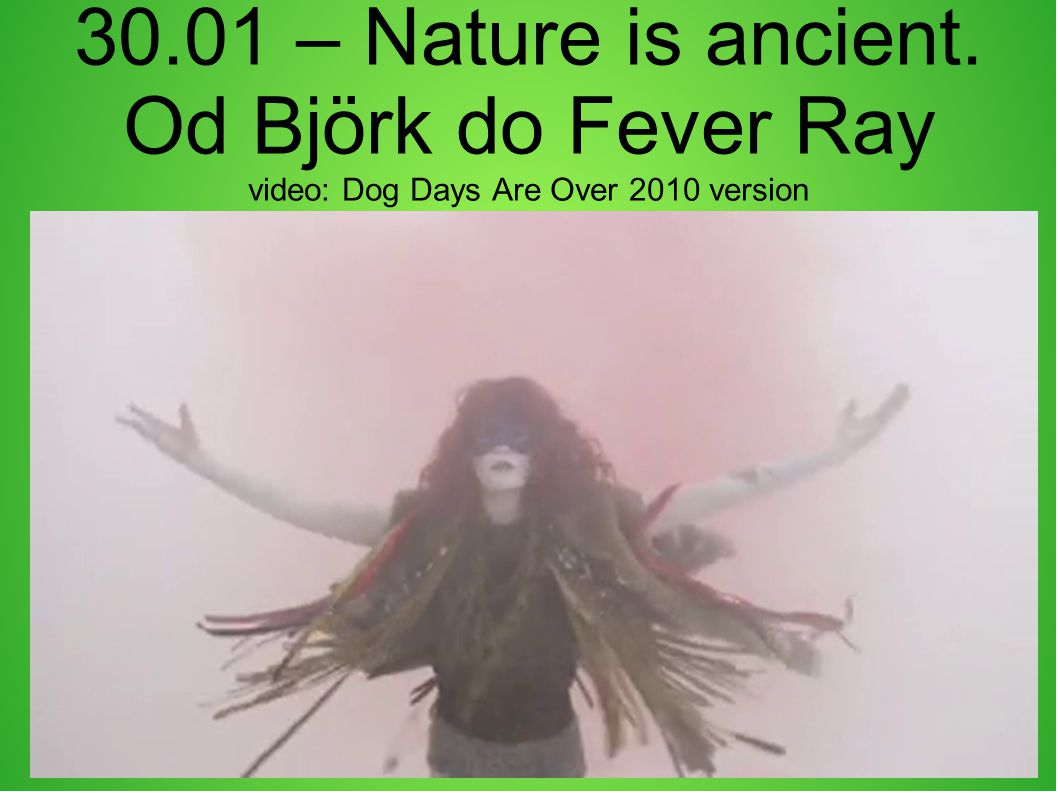Imagine the figure is a character in a novel. What would be their backstory? In a novel, this figure could be portrayed as a once revered shaman or a mystical guide, shrouded in folklore and mystery. They hail from an ancient tribe that believed in the power of nature to heal and transcend worldly pains. As a central character, their journey would involve a pilgrimage through a forgotten world, unearthing lost wisdom and rituals. The smoke surrounding them is both a protective shield and a manifestation of their spiritual aura, signifying their deep connection with the ethereal and the unknown. 